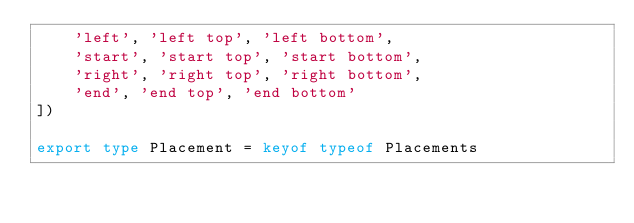Convert code to text. <code><loc_0><loc_0><loc_500><loc_500><_TypeScript_>    'left', 'left top', 'left bottom', 
    'start', 'start top', 'start bottom',
    'right', 'right top', 'right bottom',
    'end', 'end top', 'end bottom'
])

export type Placement = keyof typeof Placements
</code> 